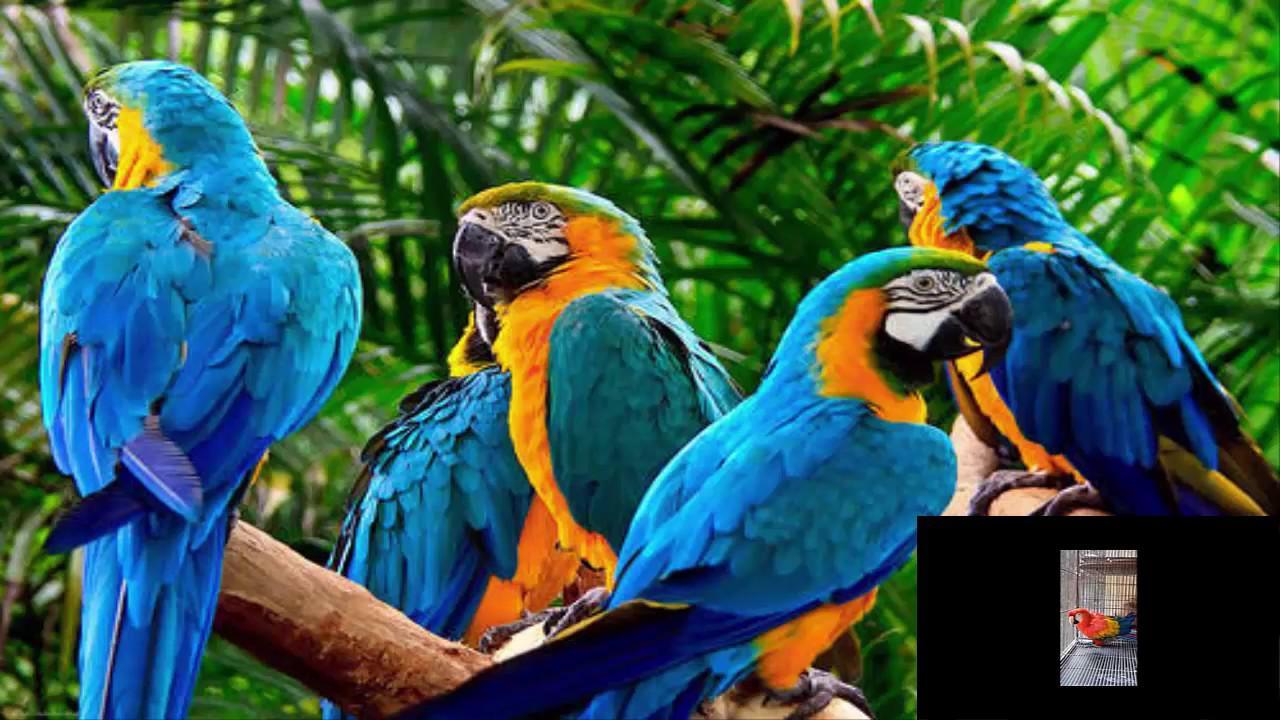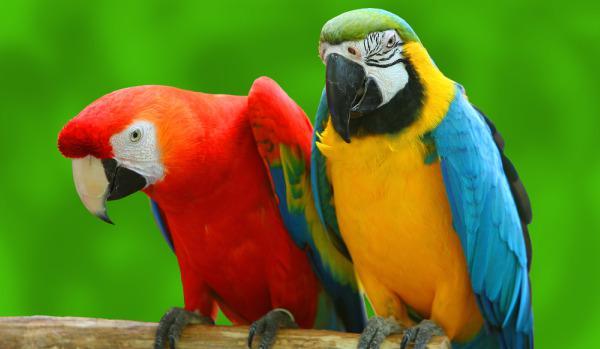The first image is the image on the left, the second image is the image on the right. Analyze the images presented: Is the assertion "There are two birds, each perched on a branch." valid? Answer yes or no. No. The first image is the image on the left, the second image is the image on the right. For the images displayed, is the sentence "There are two blue and yellow birds" factually correct? Answer yes or no. No. 